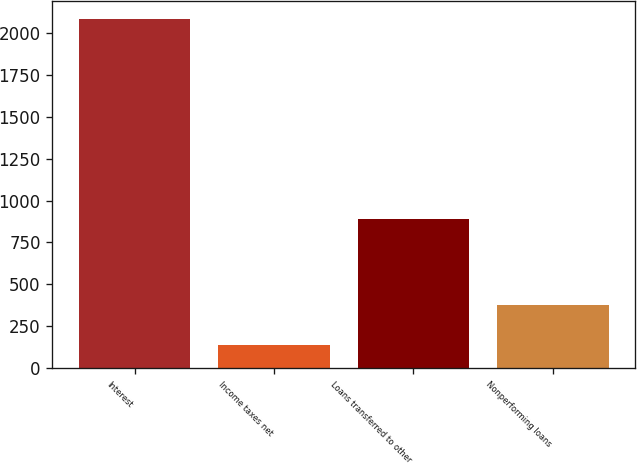<chart> <loc_0><loc_0><loc_500><loc_500><bar_chart><fcel>Interest<fcel>Income taxes net<fcel>Loans transferred to other<fcel>Nonperforming loans<nl><fcel>2086<fcel>137<fcel>890<fcel>374<nl></chart> 